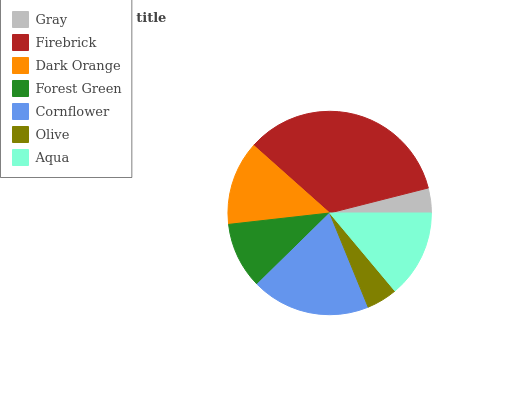Is Gray the minimum?
Answer yes or no. Yes. Is Firebrick the maximum?
Answer yes or no. Yes. Is Dark Orange the minimum?
Answer yes or no. No. Is Dark Orange the maximum?
Answer yes or no. No. Is Firebrick greater than Dark Orange?
Answer yes or no. Yes. Is Dark Orange less than Firebrick?
Answer yes or no. Yes. Is Dark Orange greater than Firebrick?
Answer yes or no. No. Is Firebrick less than Dark Orange?
Answer yes or no. No. Is Dark Orange the high median?
Answer yes or no. Yes. Is Dark Orange the low median?
Answer yes or no. Yes. Is Cornflower the high median?
Answer yes or no. No. Is Aqua the low median?
Answer yes or no. No. 